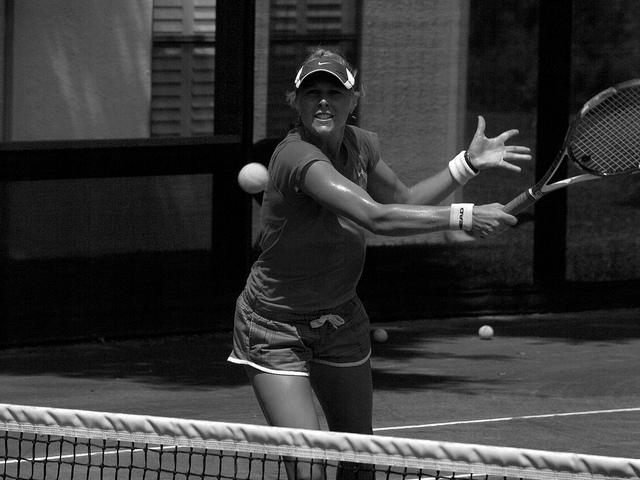What color hat is this tennis player wearing?
Be succinct. Black. What is in the lady's hand?
Keep it brief. Racket. What sport is this?
Answer briefly. Tennis. 